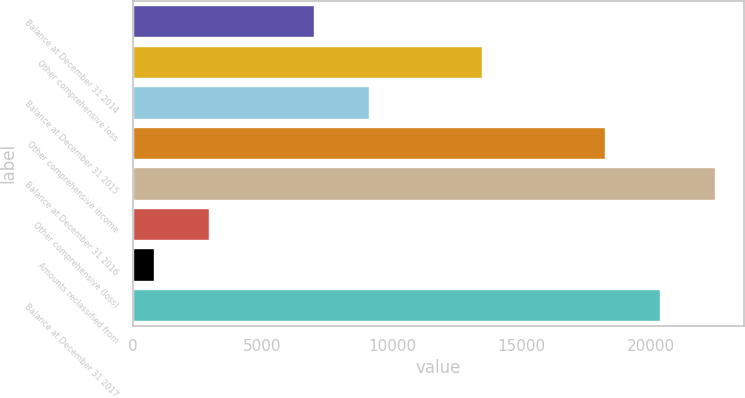Convert chart to OTSL. <chart><loc_0><loc_0><loc_500><loc_500><bar_chart><fcel>Balance at December 31 2014<fcel>Other comprehensive loss<fcel>Balance at December 31 2015<fcel>Other comprehensive income<fcel>Balance at December 31 2016<fcel>Other comprehensive (loss)<fcel>Amounts reclassified from<fcel>Balance at December 31 2017<nl><fcel>6980<fcel>13467<fcel>9113.7<fcel>18211<fcel>22478.4<fcel>2933.7<fcel>800<fcel>20344.7<nl></chart> 